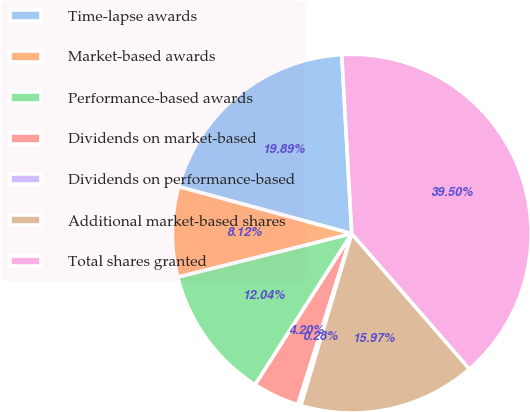<chart> <loc_0><loc_0><loc_500><loc_500><pie_chart><fcel>Time-lapse awards<fcel>Market-based awards<fcel>Performance-based awards<fcel>Dividends on market-based<fcel>Dividends on performance-based<fcel>Additional market-based shares<fcel>Total shares granted<nl><fcel>19.89%<fcel>8.12%<fcel>12.04%<fcel>4.2%<fcel>0.28%<fcel>15.97%<fcel>39.5%<nl></chart> 